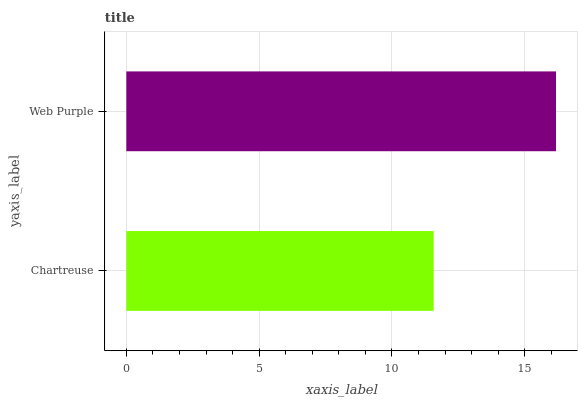Is Chartreuse the minimum?
Answer yes or no. Yes. Is Web Purple the maximum?
Answer yes or no. Yes. Is Web Purple the minimum?
Answer yes or no. No. Is Web Purple greater than Chartreuse?
Answer yes or no. Yes. Is Chartreuse less than Web Purple?
Answer yes or no. Yes. Is Chartreuse greater than Web Purple?
Answer yes or no. No. Is Web Purple less than Chartreuse?
Answer yes or no. No. Is Web Purple the high median?
Answer yes or no. Yes. Is Chartreuse the low median?
Answer yes or no. Yes. Is Chartreuse the high median?
Answer yes or no. No. Is Web Purple the low median?
Answer yes or no. No. 